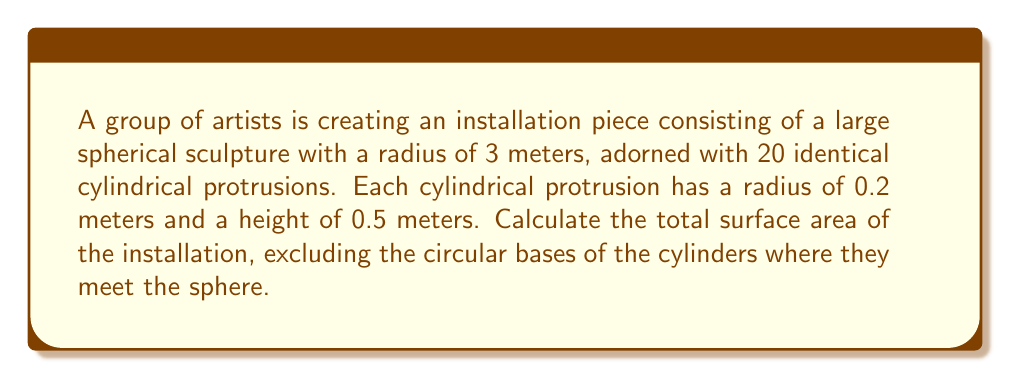What is the answer to this math problem? Let's break this down step-by-step:

1. Calculate the surface area of the sphere:
   $$A_{sphere} = 4\pi r^2 = 4\pi (3)^2 = 36\pi \text{ m}^2$$

2. Calculate the lateral surface area of one cylindrical protrusion:
   $$A_{cylinder} = 2\pi rh = 2\pi (0.2)(0.5) = 0.2\pi \text{ m}^2$$

3. Calculate the total surface area of all 20 cylindrical protrusions:
   $$A_{total cylinders} = 20 \times 0.2\pi = 4\pi \text{ m}^2$$

4. Calculate the area of one circular base where a cylinder meets the sphere:
   $$A_{base} = \pi r^2 = \pi (0.2)^2 = 0.04\pi \text{ m}^2$$

5. Calculate the total area of all 20 circular bases:
   $$A_{total bases} = 20 \times 0.04\pi = 0.8\pi \text{ m}^2$$

6. Subtract the total base area from the sphere's surface area:
   $$A_{sphere adjusted} = 36\pi - 0.8\pi = 35.2\pi \text{ m}^2$$

7. Sum the adjusted sphere area and the total cylinder area:
   $$A_{total} = A_{sphere adjusted} + A_{total cylinders} = 35.2\pi + 4\pi = 39.2\pi \text{ m}^2$$

Therefore, the total surface area of the installation is $39.2\pi \text{ m}^2$.
Answer: $39.2\pi \text{ m}^2$ 